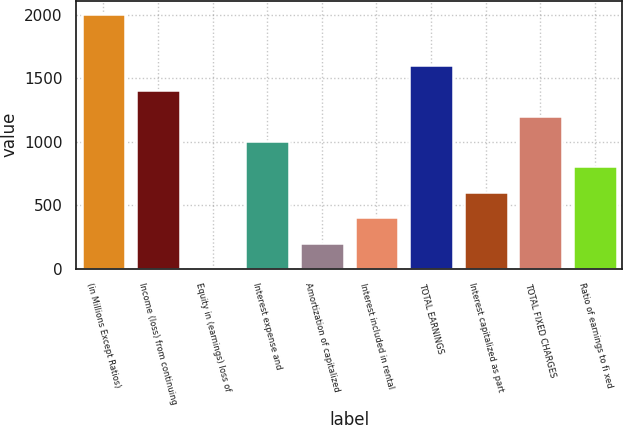<chart> <loc_0><loc_0><loc_500><loc_500><bar_chart><fcel>(in Millions Except Ratios)<fcel>Income (loss) from continuing<fcel>Equity in (earnings) loss of<fcel>Interest expense and<fcel>Amortization of capitalized<fcel>Interest included in rental<fcel>TOTAL EARNINGS<fcel>Interest capitalized as part<fcel>TOTAL FIXED CHARGES<fcel>Ratio of earnings to fi xed<nl><fcel>2010<fcel>1407.81<fcel>2.7<fcel>1006.35<fcel>203.43<fcel>404.16<fcel>1608.54<fcel>604.89<fcel>1207.08<fcel>805.62<nl></chart> 